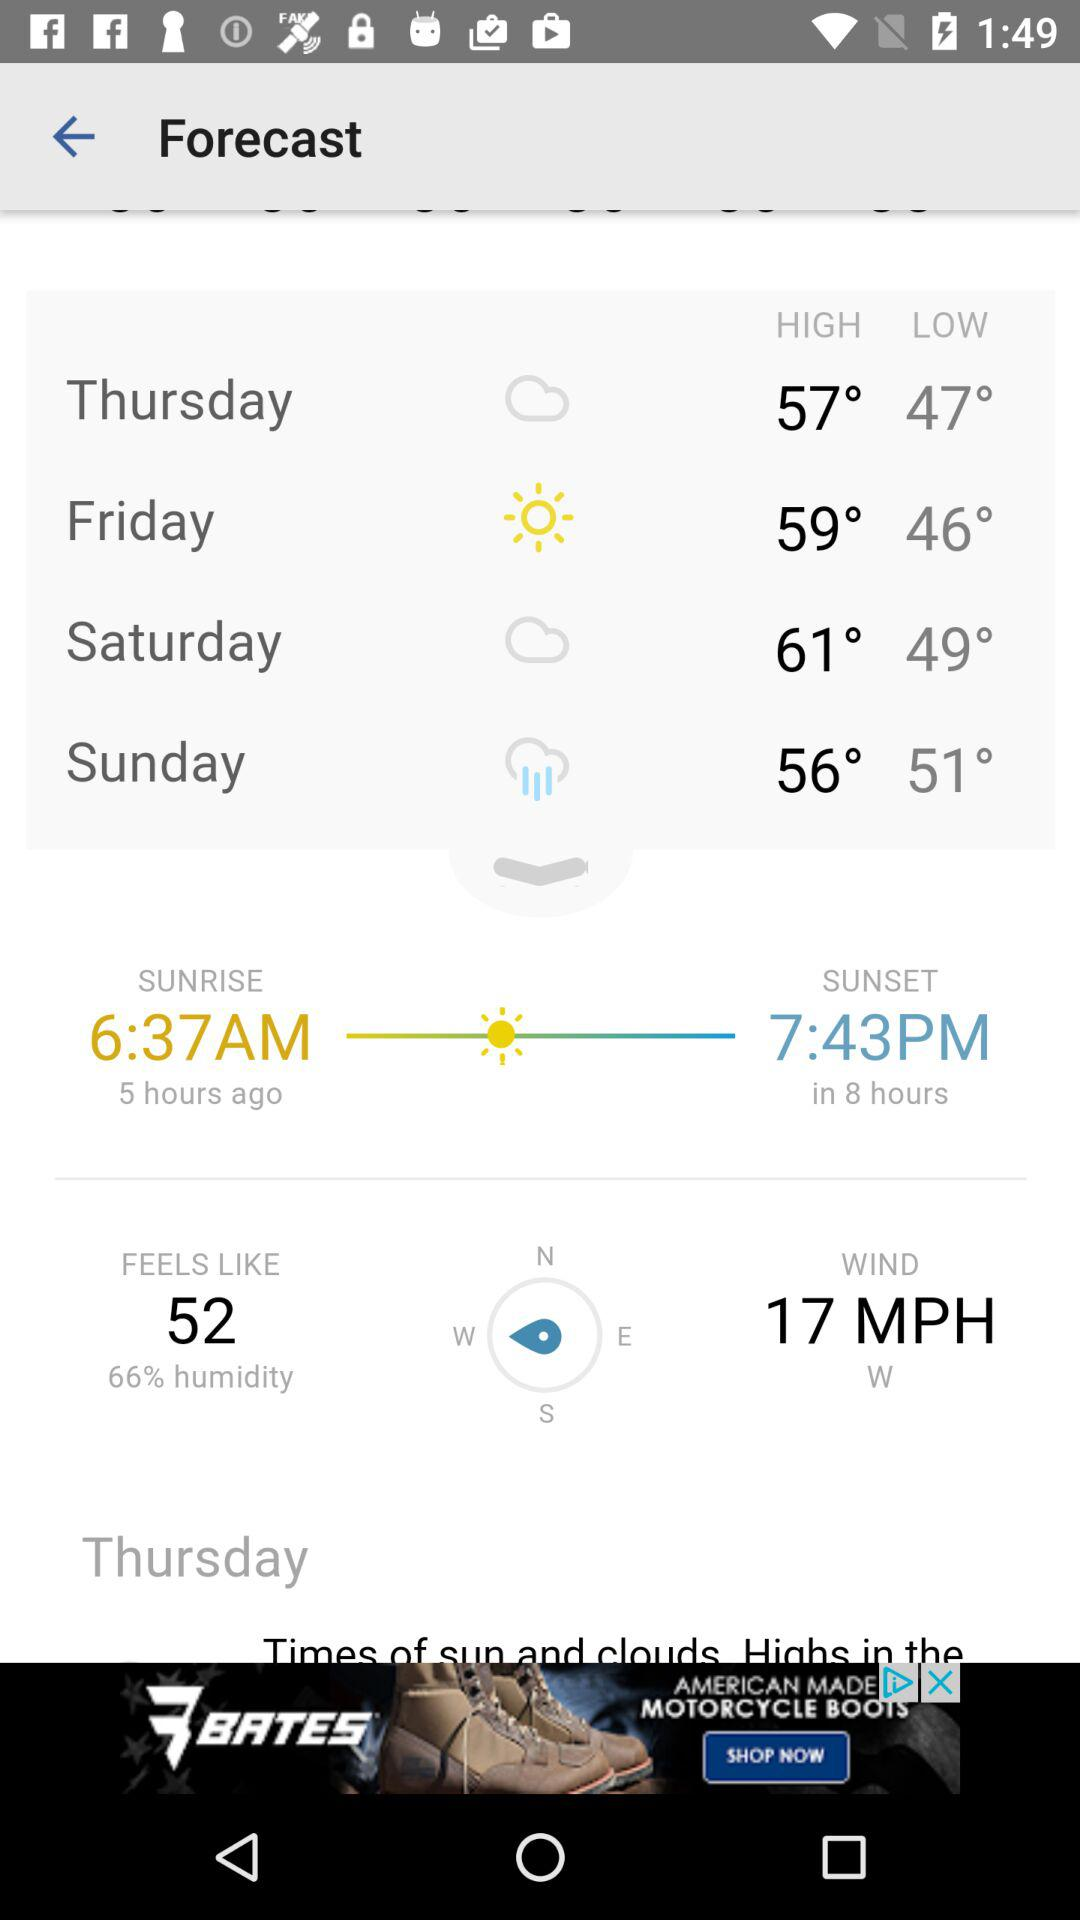What is Saturday's high temperature? The Saturday's high temperature is 61°. 